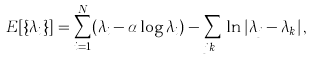<formula> <loc_0><loc_0><loc_500><loc_500>E [ \{ \lambda _ { i } \} ] = \sum _ { i = 1 } ^ { N } ( \lambda _ { i } - \alpha \log \lambda _ { i } ) - \sum _ { j \neq k } \ln | \lambda _ { j } - \lambda _ { k } | \, ,</formula> 